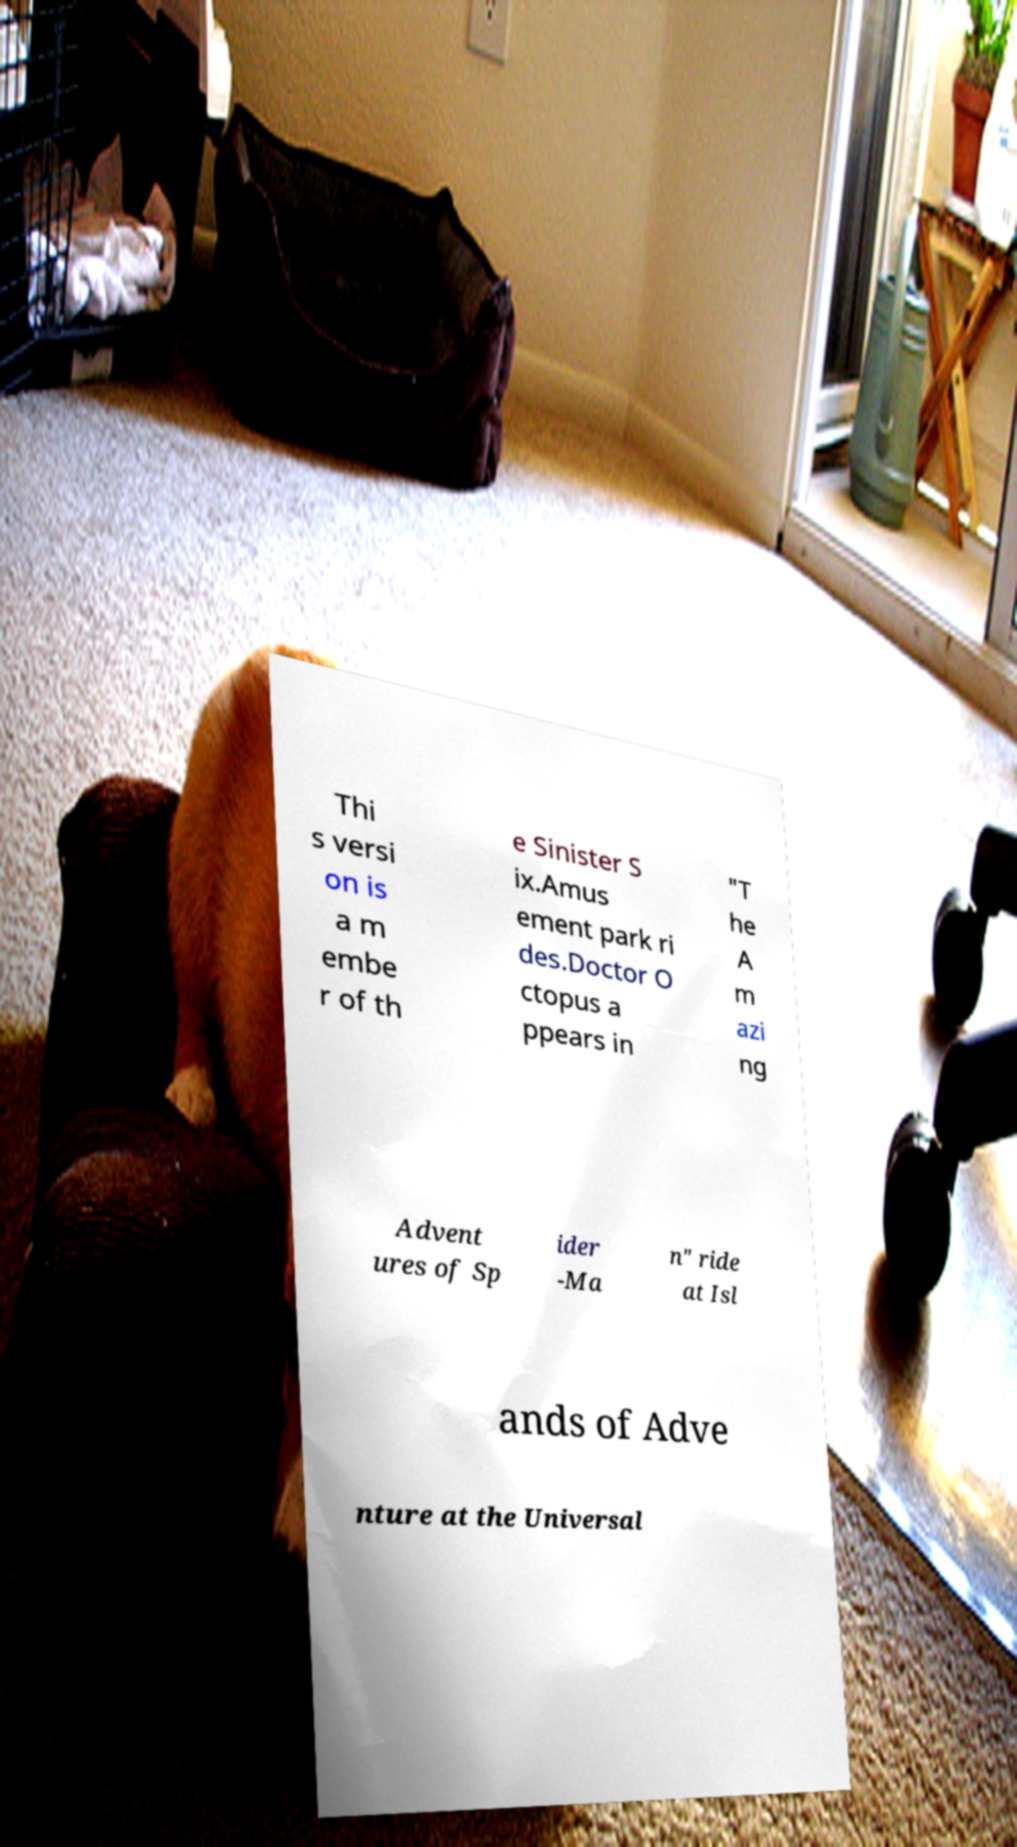What messages or text are displayed in this image? I need them in a readable, typed format. Thi s versi on is a m embe r of th e Sinister S ix.Amus ement park ri des.Doctor O ctopus a ppears in "T he A m azi ng Advent ures of Sp ider -Ma n" ride at Isl ands of Adve nture at the Universal 